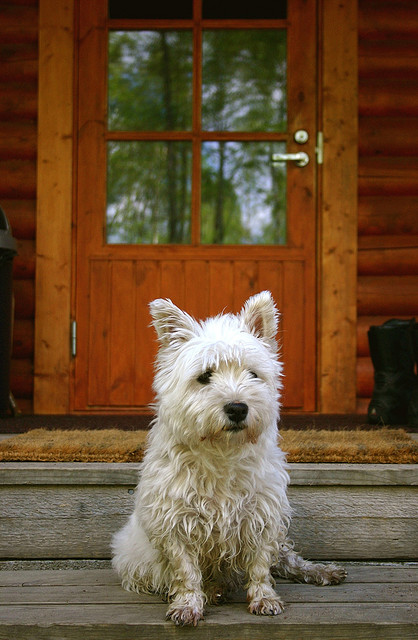Could you tell me more about the ideal living conditions for this breed? Absolutely, West Highland White Terriers thrive in environments where they can get plenty of exercise and mental stimulation. Despite their small size, they do well in both apartments and houses with yards, as long as they have ample opportunity for play and daily walks. They're also quite adaptable to varying climates, but their white coats can require regular grooming to keep them clean and mat-free. 